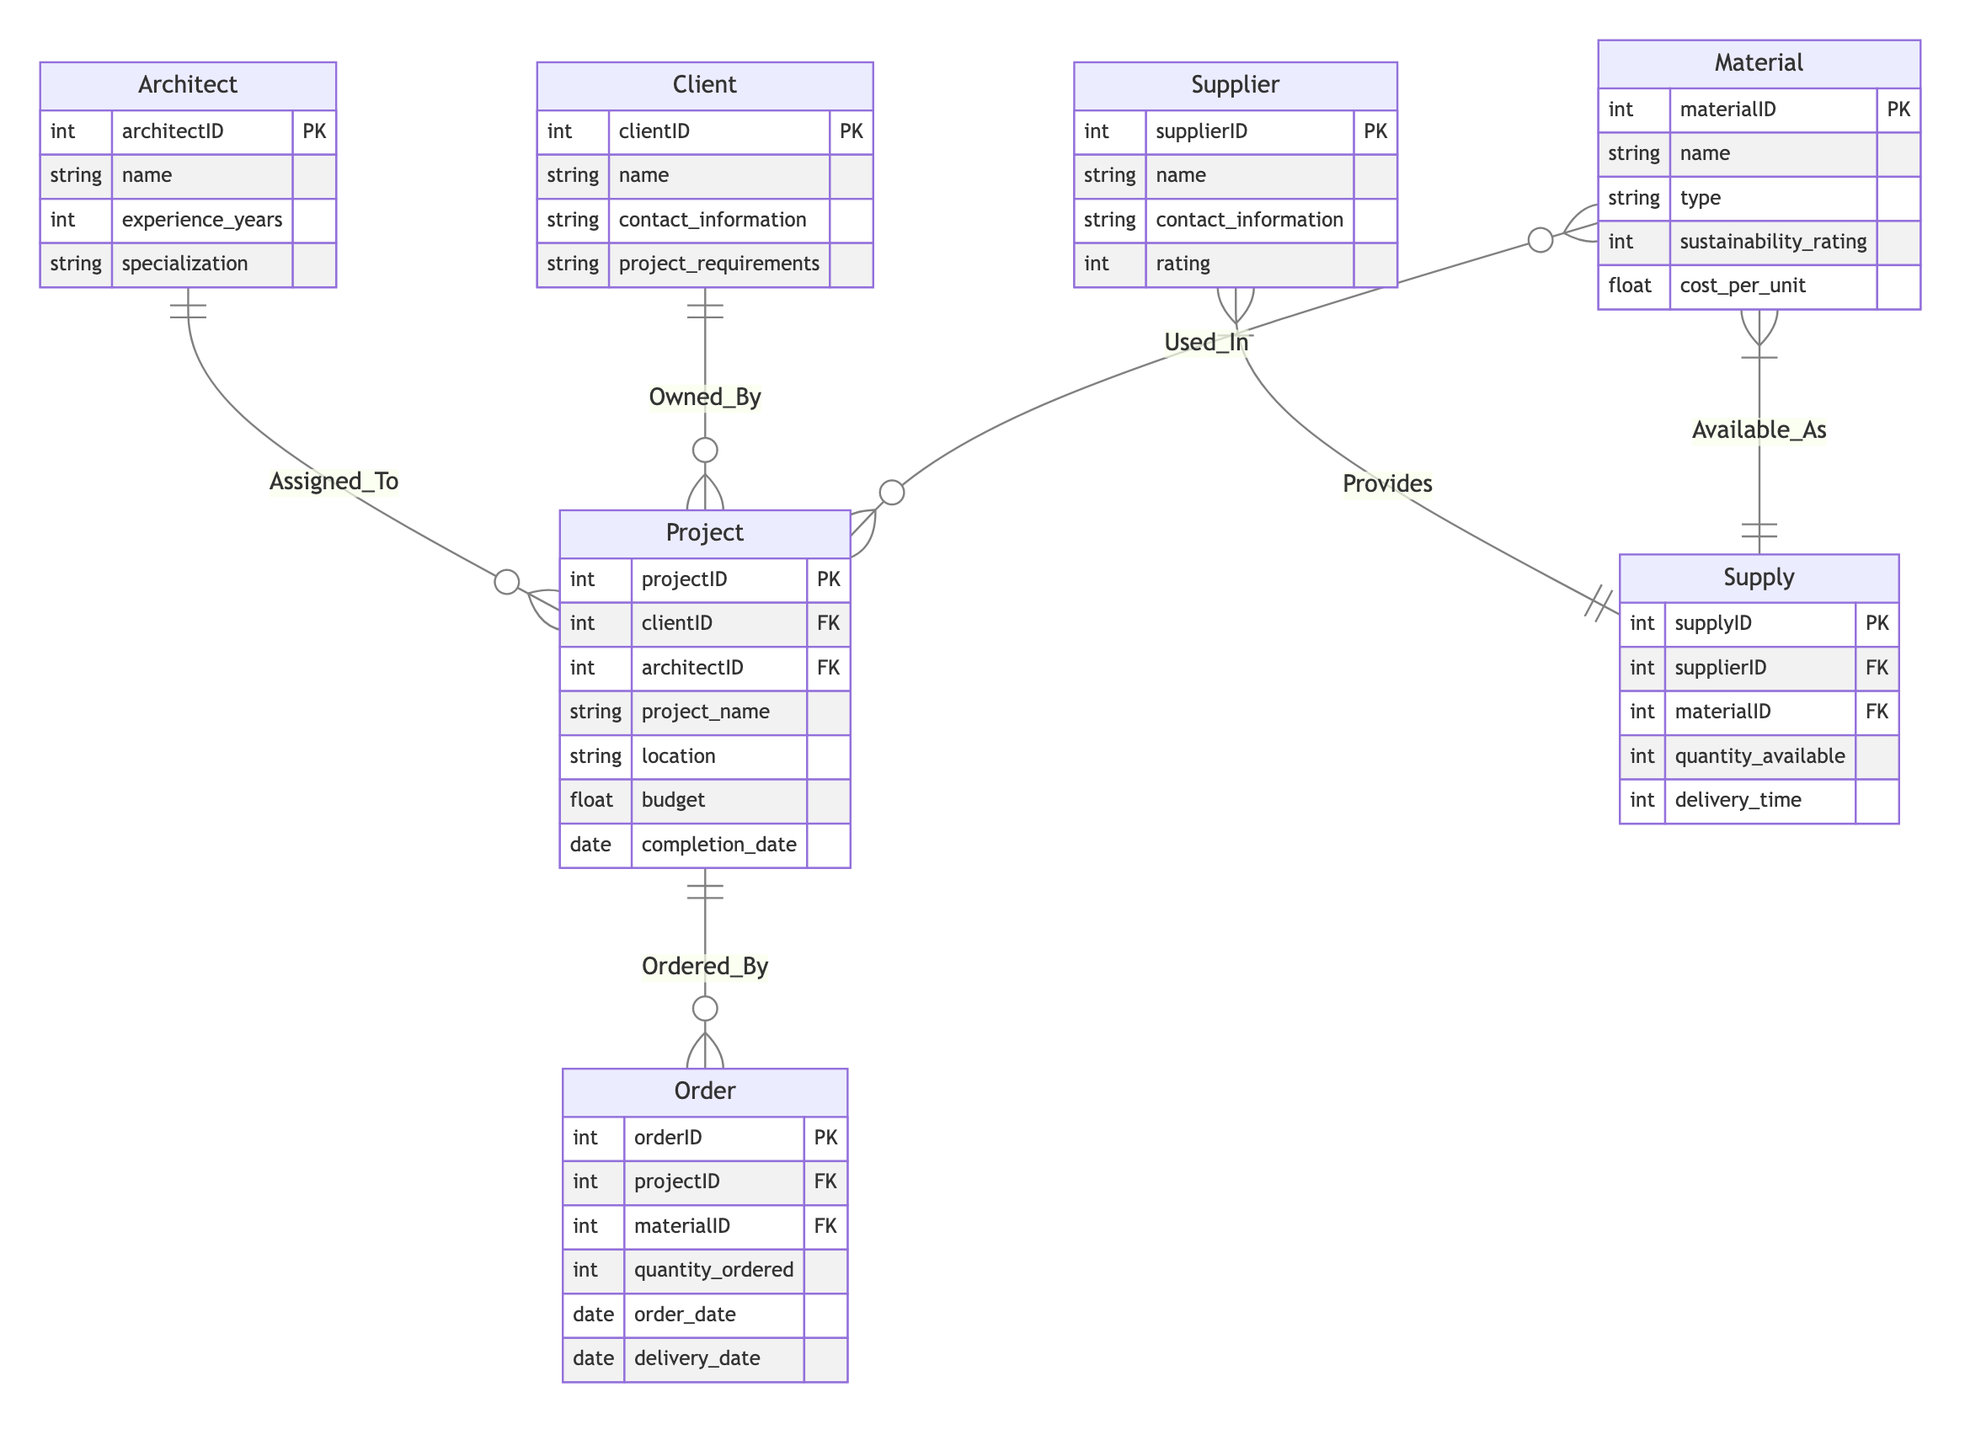What is the primary key of the Client entity? The Client entity has a primary key attribute called "clientID," which uniquely identifies each client in the relationship.
Answer: clientID How many attributes does the Material entity have? The Material entity is defined with four attributes: materialID, name, type, sustainability rating, and cost per unit, totaling five attributes.
Answer: five What type of relationship exists between Supplier and Material? The relationship between Supplier and Material is many-to-many, which is indicated by the notation "M-N." This signifies that a supplier can provide multiple materials and that a material can come from multiple suppliers.
Answer: many-to-many Which entity is involved in the relationship called "Ordered_By"? The "Ordered_By" relationship involves the Project and Order entities, indicating that a project can have multiple orders associated with it.
Answer: Project and Order How many entities are connected to the Architect entity? The Architect entity has one direct relationship with the Project entity, showing that one architect can be assigned to multiple projects, giving a total of one connection mapped in the diagram.
Answer: one What is the foreign key in the Project entity that relates to the Client entity? The foreign key in the Project entity that relates to the Client entity is "clientID," which links each project to the corresponding client owner.
Answer: clientID Which entity has the highest number of relationships in the diagram? The Project entity is involved in five relationships: it connects with Architect, Client, Order, and Material through the different relationships depicted, making it the entity with the highest number of relationships in the diagram.
Answer: Project What is the attribute that links Supply and Material entities? The attribute that links the Supply and Material entities is "materialID," which is a foreign key in the Supply entity that links back to the Material entity to indicate what material is supplied.
Answer: materialID What type of relationship is "Used_In"? The "Used_In" relationship is categorized as a many-to-many relationship, indicating that materials can be used in multiple projects, and projects can utilize multiple materials.
Answer: many-to-many 